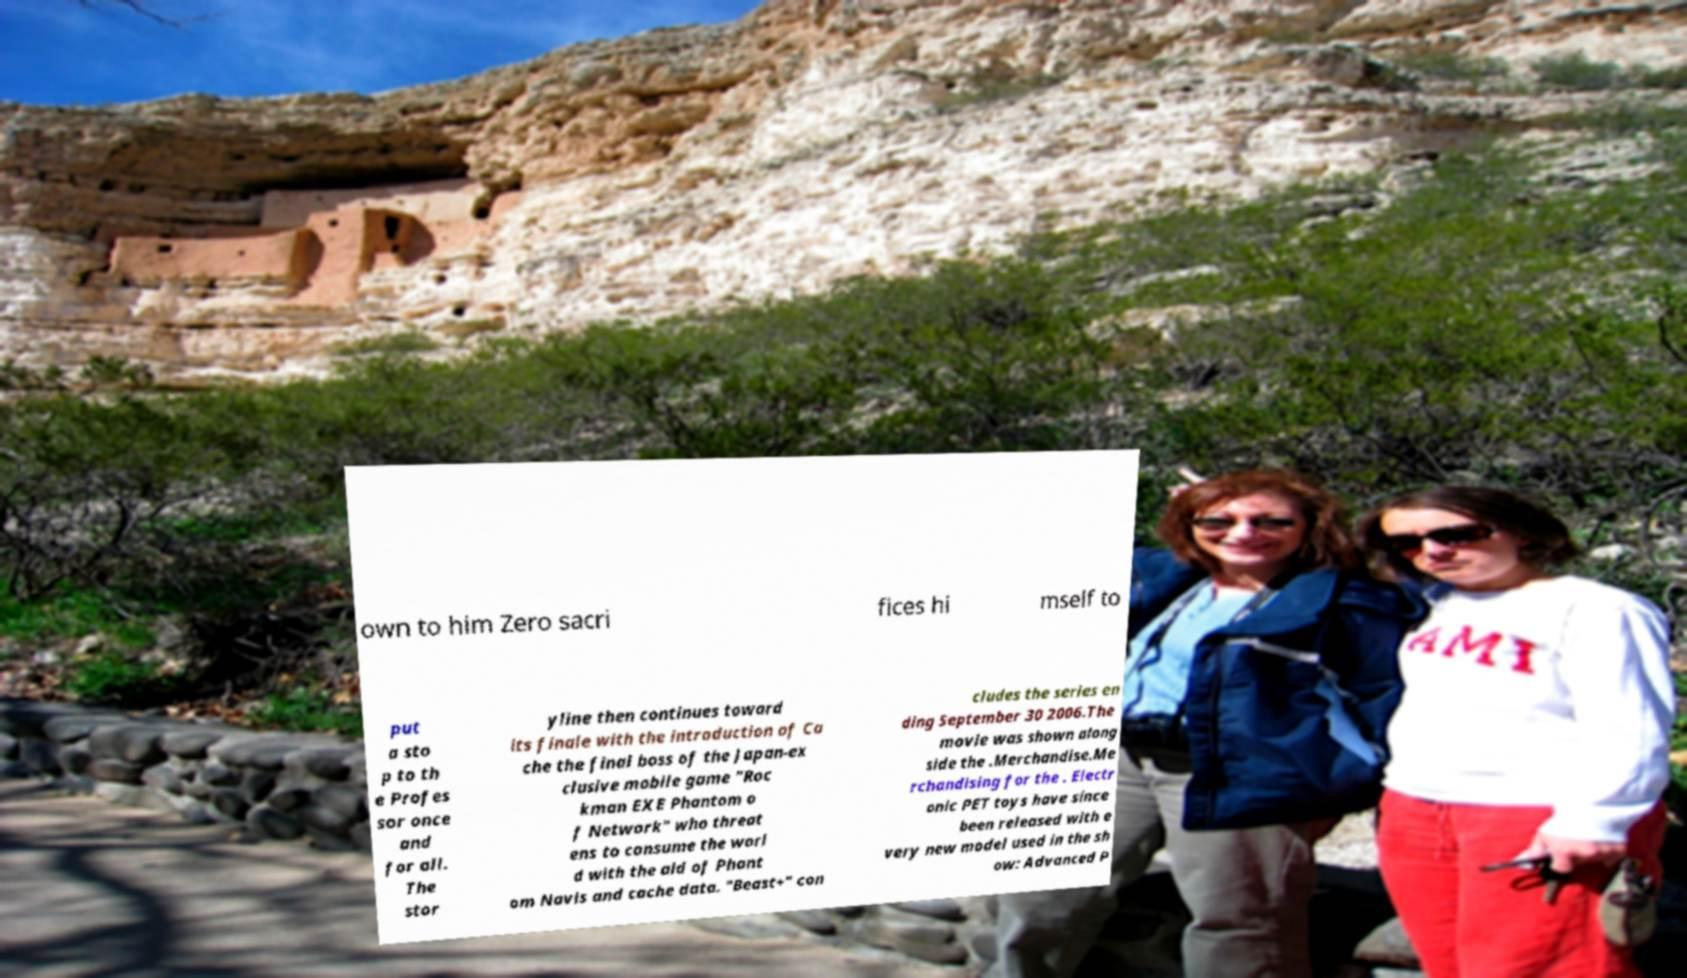Can you accurately transcribe the text from the provided image for me? own to him Zero sacri fices hi mself to put a sto p to th e Profes sor once and for all. The stor yline then continues toward its finale with the introduction of Ca che the final boss of the Japan-ex clusive mobile game "Roc kman EXE Phantom o f Network" who threat ens to consume the worl d with the aid of Phant om Navis and cache data. "Beast+" con cludes the series en ding September 30 2006.The movie was shown along side the .Merchandise.Me rchandising for the . Electr onic PET toys have since been released with e very new model used in the sh ow: Advanced P 